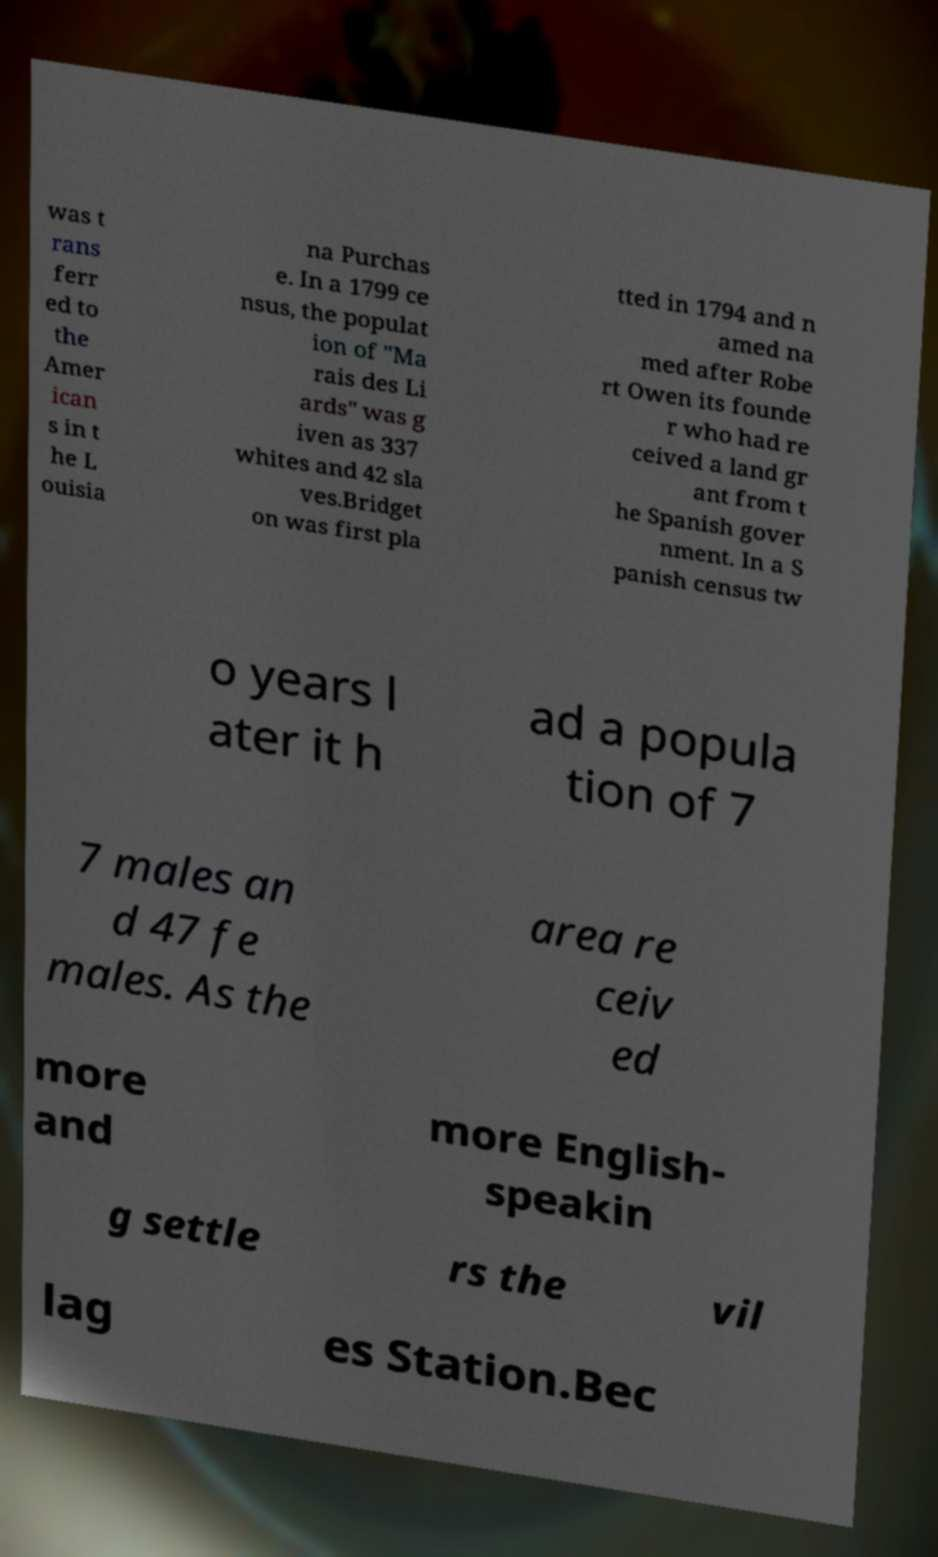Could you extract and type out the text from this image? was t rans ferr ed to the Amer ican s in t he L ouisia na Purchas e. In a 1799 ce nsus, the populat ion of "Ma rais des Li ards" was g iven as 337 whites and 42 sla ves.Bridget on was first pla tted in 1794 and n amed na med after Robe rt Owen its founde r who had re ceived a land gr ant from t he Spanish gover nment. In a S panish census tw o years l ater it h ad a popula tion of 7 7 males an d 47 fe males. As the area re ceiv ed more and more English- speakin g settle rs the vil lag es Station.Bec 